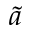<formula> <loc_0><loc_0><loc_500><loc_500>\tilde { a }</formula> 